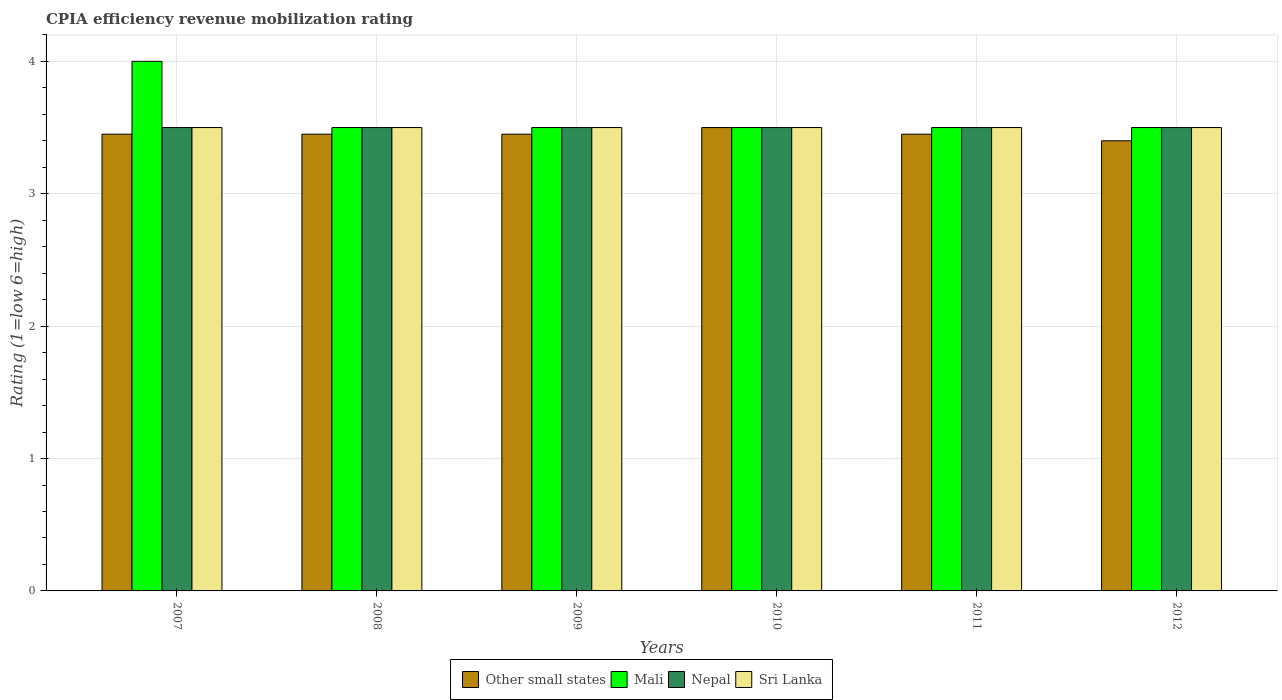How many different coloured bars are there?
Offer a terse response. 4. How many groups of bars are there?
Ensure brevity in your answer.  6. How many bars are there on the 6th tick from the right?
Your answer should be compact. 4. In how many cases, is the number of bars for a given year not equal to the number of legend labels?
Your response must be concise. 0. In which year was the CPIA rating in Nepal maximum?
Offer a very short reply. 2007. In which year was the CPIA rating in Sri Lanka minimum?
Offer a very short reply. 2007. What is the total CPIA rating in Mali in the graph?
Offer a very short reply. 21.5. What is the difference between the CPIA rating in Mali in 2007 and the CPIA rating in Nepal in 2008?
Offer a very short reply. 0.5. What is the average CPIA rating in Other small states per year?
Your answer should be very brief. 3.45. What is the ratio of the CPIA rating in Other small states in 2008 to that in 2011?
Give a very brief answer. 1. In how many years, is the CPIA rating in Mali greater than the average CPIA rating in Mali taken over all years?
Your answer should be very brief. 1. Is the sum of the CPIA rating in Mali in 2008 and 2012 greater than the maximum CPIA rating in Nepal across all years?
Your answer should be compact. Yes. Is it the case that in every year, the sum of the CPIA rating in Other small states and CPIA rating in Mali is greater than the sum of CPIA rating in Nepal and CPIA rating in Sri Lanka?
Your response must be concise. No. What does the 3rd bar from the left in 2008 represents?
Your answer should be very brief. Nepal. What does the 4th bar from the right in 2011 represents?
Your response must be concise. Other small states. Are all the bars in the graph horizontal?
Your answer should be compact. No. Are the values on the major ticks of Y-axis written in scientific E-notation?
Provide a short and direct response. No. Does the graph contain any zero values?
Your answer should be compact. No. Where does the legend appear in the graph?
Give a very brief answer. Bottom center. How many legend labels are there?
Your answer should be compact. 4. How are the legend labels stacked?
Keep it short and to the point. Horizontal. What is the title of the graph?
Offer a very short reply. CPIA efficiency revenue mobilization rating. What is the label or title of the X-axis?
Offer a very short reply. Years. What is the Rating (1=low 6=high) of Other small states in 2007?
Offer a terse response. 3.45. What is the Rating (1=low 6=high) of Mali in 2007?
Provide a succinct answer. 4. What is the Rating (1=low 6=high) in Nepal in 2007?
Your response must be concise. 3.5. What is the Rating (1=low 6=high) in Other small states in 2008?
Offer a very short reply. 3.45. What is the Rating (1=low 6=high) in Mali in 2008?
Provide a short and direct response. 3.5. What is the Rating (1=low 6=high) in Other small states in 2009?
Your answer should be compact. 3.45. What is the Rating (1=low 6=high) in Mali in 2009?
Offer a very short reply. 3.5. What is the Rating (1=low 6=high) of Mali in 2010?
Provide a short and direct response. 3.5. What is the Rating (1=low 6=high) of Nepal in 2010?
Your answer should be very brief. 3.5. What is the Rating (1=low 6=high) of Other small states in 2011?
Give a very brief answer. 3.45. What is the Rating (1=low 6=high) in Other small states in 2012?
Your response must be concise. 3.4. What is the Rating (1=low 6=high) in Mali in 2012?
Give a very brief answer. 3.5. What is the Rating (1=low 6=high) of Nepal in 2012?
Your answer should be compact. 3.5. Across all years, what is the maximum Rating (1=low 6=high) in Mali?
Make the answer very short. 4. Across all years, what is the maximum Rating (1=low 6=high) in Nepal?
Your answer should be compact. 3.5. Across all years, what is the minimum Rating (1=low 6=high) of Other small states?
Offer a terse response. 3.4. Across all years, what is the minimum Rating (1=low 6=high) in Mali?
Make the answer very short. 3.5. Across all years, what is the minimum Rating (1=low 6=high) of Sri Lanka?
Keep it short and to the point. 3.5. What is the total Rating (1=low 6=high) of Other small states in the graph?
Provide a short and direct response. 20.7. What is the total Rating (1=low 6=high) in Mali in the graph?
Your answer should be compact. 21.5. What is the total Rating (1=low 6=high) of Sri Lanka in the graph?
Offer a very short reply. 21. What is the difference between the Rating (1=low 6=high) in Other small states in 2007 and that in 2008?
Your answer should be compact. 0. What is the difference between the Rating (1=low 6=high) of Sri Lanka in 2007 and that in 2008?
Offer a terse response. 0. What is the difference between the Rating (1=low 6=high) of Other small states in 2007 and that in 2009?
Give a very brief answer. 0. What is the difference between the Rating (1=low 6=high) in Nepal in 2007 and that in 2009?
Offer a terse response. 0. What is the difference between the Rating (1=low 6=high) in Sri Lanka in 2007 and that in 2009?
Make the answer very short. 0. What is the difference between the Rating (1=low 6=high) in Other small states in 2007 and that in 2010?
Your response must be concise. -0.05. What is the difference between the Rating (1=low 6=high) in Mali in 2007 and that in 2010?
Your response must be concise. 0.5. What is the difference between the Rating (1=low 6=high) in Mali in 2007 and that in 2011?
Give a very brief answer. 0.5. What is the difference between the Rating (1=low 6=high) in Nepal in 2007 and that in 2011?
Make the answer very short. 0. What is the difference between the Rating (1=low 6=high) of Other small states in 2007 and that in 2012?
Ensure brevity in your answer.  0.05. What is the difference between the Rating (1=low 6=high) in Mali in 2007 and that in 2012?
Provide a succinct answer. 0.5. What is the difference between the Rating (1=low 6=high) in Nepal in 2007 and that in 2012?
Keep it short and to the point. 0. What is the difference between the Rating (1=low 6=high) of Sri Lanka in 2007 and that in 2012?
Provide a short and direct response. 0. What is the difference between the Rating (1=low 6=high) of Mali in 2008 and that in 2009?
Ensure brevity in your answer.  0. What is the difference between the Rating (1=low 6=high) in Sri Lanka in 2008 and that in 2009?
Keep it short and to the point. 0. What is the difference between the Rating (1=low 6=high) of Other small states in 2008 and that in 2010?
Keep it short and to the point. -0.05. What is the difference between the Rating (1=low 6=high) of Mali in 2008 and that in 2010?
Ensure brevity in your answer.  0. What is the difference between the Rating (1=low 6=high) in Other small states in 2008 and that in 2011?
Your answer should be compact. 0. What is the difference between the Rating (1=low 6=high) in Nepal in 2008 and that in 2011?
Offer a very short reply. 0. What is the difference between the Rating (1=low 6=high) in Other small states in 2008 and that in 2012?
Ensure brevity in your answer.  0.05. What is the difference between the Rating (1=low 6=high) of Mali in 2008 and that in 2012?
Provide a short and direct response. 0. What is the difference between the Rating (1=low 6=high) of Nepal in 2008 and that in 2012?
Your answer should be very brief. 0. What is the difference between the Rating (1=low 6=high) of Other small states in 2009 and that in 2011?
Your answer should be compact. 0. What is the difference between the Rating (1=low 6=high) of Nepal in 2009 and that in 2011?
Your answer should be compact. 0. What is the difference between the Rating (1=low 6=high) of Other small states in 2009 and that in 2012?
Provide a succinct answer. 0.05. What is the difference between the Rating (1=low 6=high) in Mali in 2009 and that in 2012?
Make the answer very short. 0. What is the difference between the Rating (1=low 6=high) in Nepal in 2009 and that in 2012?
Keep it short and to the point. 0. What is the difference between the Rating (1=low 6=high) in Sri Lanka in 2009 and that in 2012?
Your answer should be compact. 0. What is the difference between the Rating (1=low 6=high) in Nepal in 2010 and that in 2012?
Provide a short and direct response. 0. What is the difference between the Rating (1=low 6=high) of Other small states in 2011 and that in 2012?
Your answer should be compact. 0.05. What is the difference between the Rating (1=low 6=high) of Mali in 2011 and that in 2012?
Ensure brevity in your answer.  0. What is the difference between the Rating (1=low 6=high) in Other small states in 2007 and the Rating (1=low 6=high) in Mali in 2008?
Your response must be concise. -0.05. What is the difference between the Rating (1=low 6=high) in Other small states in 2007 and the Rating (1=low 6=high) in Sri Lanka in 2008?
Provide a short and direct response. -0.05. What is the difference between the Rating (1=low 6=high) in Other small states in 2007 and the Rating (1=low 6=high) in Mali in 2009?
Provide a short and direct response. -0.05. What is the difference between the Rating (1=low 6=high) in Other small states in 2007 and the Rating (1=low 6=high) in Sri Lanka in 2009?
Provide a succinct answer. -0.05. What is the difference between the Rating (1=low 6=high) of Mali in 2007 and the Rating (1=low 6=high) of Nepal in 2009?
Offer a terse response. 0.5. What is the difference between the Rating (1=low 6=high) of Mali in 2007 and the Rating (1=low 6=high) of Sri Lanka in 2009?
Provide a short and direct response. 0.5. What is the difference between the Rating (1=low 6=high) in Nepal in 2007 and the Rating (1=low 6=high) in Sri Lanka in 2009?
Ensure brevity in your answer.  0. What is the difference between the Rating (1=low 6=high) in Other small states in 2007 and the Rating (1=low 6=high) in Nepal in 2010?
Keep it short and to the point. -0.05. What is the difference between the Rating (1=low 6=high) of Other small states in 2007 and the Rating (1=low 6=high) of Sri Lanka in 2010?
Ensure brevity in your answer.  -0.05. What is the difference between the Rating (1=low 6=high) in Mali in 2007 and the Rating (1=low 6=high) in Nepal in 2011?
Provide a succinct answer. 0.5. What is the difference between the Rating (1=low 6=high) in Mali in 2007 and the Rating (1=low 6=high) in Sri Lanka in 2011?
Ensure brevity in your answer.  0.5. What is the difference between the Rating (1=low 6=high) in Other small states in 2007 and the Rating (1=low 6=high) in Nepal in 2012?
Your answer should be compact. -0.05. What is the difference between the Rating (1=low 6=high) of Other small states in 2007 and the Rating (1=low 6=high) of Sri Lanka in 2012?
Your answer should be very brief. -0.05. What is the difference between the Rating (1=low 6=high) of Mali in 2007 and the Rating (1=low 6=high) of Nepal in 2012?
Ensure brevity in your answer.  0.5. What is the difference between the Rating (1=low 6=high) of Other small states in 2008 and the Rating (1=low 6=high) of Mali in 2009?
Ensure brevity in your answer.  -0.05. What is the difference between the Rating (1=low 6=high) of Mali in 2008 and the Rating (1=low 6=high) of Nepal in 2009?
Keep it short and to the point. 0. What is the difference between the Rating (1=low 6=high) of Mali in 2008 and the Rating (1=low 6=high) of Sri Lanka in 2009?
Keep it short and to the point. 0. What is the difference between the Rating (1=low 6=high) of Nepal in 2008 and the Rating (1=low 6=high) of Sri Lanka in 2009?
Offer a very short reply. 0. What is the difference between the Rating (1=low 6=high) of Other small states in 2008 and the Rating (1=low 6=high) of Mali in 2010?
Offer a very short reply. -0.05. What is the difference between the Rating (1=low 6=high) of Mali in 2008 and the Rating (1=low 6=high) of Nepal in 2010?
Your response must be concise. 0. What is the difference between the Rating (1=low 6=high) in Mali in 2008 and the Rating (1=low 6=high) in Sri Lanka in 2010?
Provide a succinct answer. 0. What is the difference between the Rating (1=low 6=high) of Nepal in 2008 and the Rating (1=low 6=high) of Sri Lanka in 2010?
Offer a very short reply. 0. What is the difference between the Rating (1=low 6=high) in Other small states in 2008 and the Rating (1=low 6=high) in Mali in 2011?
Give a very brief answer. -0.05. What is the difference between the Rating (1=low 6=high) in Other small states in 2008 and the Rating (1=low 6=high) in Nepal in 2011?
Your answer should be compact. -0.05. What is the difference between the Rating (1=low 6=high) in Other small states in 2008 and the Rating (1=low 6=high) in Mali in 2012?
Offer a very short reply. -0.05. What is the difference between the Rating (1=low 6=high) in Other small states in 2008 and the Rating (1=low 6=high) in Sri Lanka in 2012?
Give a very brief answer. -0.05. What is the difference between the Rating (1=low 6=high) in Mali in 2008 and the Rating (1=low 6=high) in Sri Lanka in 2012?
Offer a terse response. 0. What is the difference between the Rating (1=low 6=high) in Other small states in 2009 and the Rating (1=low 6=high) in Nepal in 2010?
Your answer should be very brief. -0.05. What is the difference between the Rating (1=low 6=high) in Other small states in 2009 and the Rating (1=low 6=high) in Sri Lanka in 2010?
Provide a succinct answer. -0.05. What is the difference between the Rating (1=low 6=high) in Mali in 2009 and the Rating (1=low 6=high) in Nepal in 2010?
Your answer should be compact. 0. What is the difference between the Rating (1=low 6=high) in Other small states in 2009 and the Rating (1=low 6=high) in Mali in 2011?
Offer a very short reply. -0.05. What is the difference between the Rating (1=low 6=high) of Other small states in 2009 and the Rating (1=low 6=high) of Nepal in 2011?
Keep it short and to the point. -0.05. What is the difference between the Rating (1=low 6=high) in Other small states in 2009 and the Rating (1=low 6=high) in Sri Lanka in 2011?
Offer a very short reply. -0.05. What is the difference between the Rating (1=low 6=high) in Mali in 2009 and the Rating (1=low 6=high) in Nepal in 2011?
Offer a terse response. 0. What is the difference between the Rating (1=low 6=high) in Mali in 2009 and the Rating (1=low 6=high) in Sri Lanka in 2011?
Offer a terse response. 0. What is the difference between the Rating (1=low 6=high) of Other small states in 2009 and the Rating (1=low 6=high) of Mali in 2012?
Give a very brief answer. -0.05. What is the difference between the Rating (1=low 6=high) of Mali in 2009 and the Rating (1=low 6=high) of Sri Lanka in 2012?
Give a very brief answer. 0. What is the difference between the Rating (1=low 6=high) of Nepal in 2009 and the Rating (1=low 6=high) of Sri Lanka in 2012?
Offer a terse response. 0. What is the difference between the Rating (1=low 6=high) of Mali in 2010 and the Rating (1=low 6=high) of Nepal in 2011?
Ensure brevity in your answer.  0. What is the difference between the Rating (1=low 6=high) of Other small states in 2010 and the Rating (1=low 6=high) of Mali in 2012?
Your answer should be compact. 0. What is the difference between the Rating (1=low 6=high) of Other small states in 2010 and the Rating (1=low 6=high) of Nepal in 2012?
Make the answer very short. 0. What is the difference between the Rating (1=low 6=high) of Mali in 2010 and the Rating (1=low 6=high) of Nepal in 2012?
Make the answer very short. 0. What is the difference between the Rating (1=low 6=high) in Mali in 2010 and the Rating (1=low 6=high) in Sri Lanka in 2012?
Offer a terse response. 0. What is the difference between the Rating (1=low 6=high) of Nepal in 2010 and the Rating (1=low 6=high) of Sri Lanka in 2012?
Your answer should be compact. 0. What is the difference between the Rating (1=low 6=high) in Other small states in 2011 and the Rating (1=low 6=high) in Mali in 2012?
Provide a short and direct response. -0.05. What is the difference between the Rating (1=low 6=high) of Other small states in 2011 and the Rating (1=low 6=high) of Sri Lanka in 2012?
Offer a terse response. -0.05. What is the difference between the Rating (1=low 6=high) of Mali in 2011 and the Rating (1=low 6=high) of Sri Lanka in 2012?
Ensure brevity in your answer.  0. What is the average Rating (1=low 6=high) of Other small states per year?
Your response must be concise. 3.45. What is the average Rating (1=low 6=high) in Mali per year?
Offer a terse response. 3.58. What is the average Rating (1=low 6=high) of Nepal per year?
Your answer should be compact. 3.5. In the year 2007, what is the difference between the Rating (1=low 6=high) of Other small states and Rating (1=low 6=high) of Mali?
Offer a terse response. -0.55. In the year 2007, what is the difference between the Rating (1=low 6=high) of Other small states and Rating (1=low 6=high) of Nepal?
Provide a short and direct response. -0.05. In the year 2007, what is the difference between the Rating (1=low 6=high) in Other small states and Rating (1=low 6=high) in Sri Lanka?
Make the answer very short. -0.05. In the year 2007, what is the difference between the Rating (1=low 6=high) of Mali and Rating (1=low 6=high) of Sri Lanka?
Your response must be concise. 0.5. In the year 2008, what is the difference between the Rating (1=low 6=high) in Other small states and Rating (1=low 6=high) in Nepal?
Make the answer very short. -0.05. In the year 2009, what is the difference between the Rating (1=low 6=high) of Other small states and Rating (1=low 6=high) of Mali?
Offer a terse response. -0.05. In the year 2009, what is the difference between the Rating (1=low 6=high) of Other small states and Rating (1=low 6=high) of Nepal?
Provide a succinct answer. -0.05. In the year 2009, what is the difference between the Rating (1=low 6=high) in Mali and Rating (1=low 6=high) in Nepal?
Your response must be concise. 0. In the year 2009, what is the difference between the Rating (1=low 6=high) in Mali and Rating (1=low 6=high) in Sri Lanka?
Ensure brevity in your answer.  0. In the year 2009, what is the difference between the Rating (1=low 6=high) in Nepal and Rating (1=low 6=high) in Sri Lanka?
Provide a succinct answer. 0. In the year 2010, what is the difference between the Rating (1=low 6=high) of Mali and Rating (1=low 6=high) of Nepal?
Your answer should be very brief. 0. In the year 2010, what is the difference between the Rating (1=low 6=high) of Mali and Rating (1=low 6=high) of Sri Lanka?
Give a very brief answer. 0. In the year 2011, what is the difference between the Rating (1=low 6=high) in Other small states and Rating (1=low 6=high) in Mali?
Offer a terse response. -0.05. In the year 2011, what is the difference between the Rating (1=low 6=high) in Other small states and Rating (1=low 6=high) in Nepal?
Keep it short and to the point. -0.05. In the year 2011, what is the difference between the Rating (1=low 6=high) of Nepal and Rating (1=low 6=high) of Sri Lanka?
Offer a terse response. 0. In the year 2012, what is the difference between the Rating (1=low 6=high) of Mali and Rating (1=low 6=high) of Sri Lanka?
Your response must be concise. 0. What is the ratio of the Rating (1=low 6=high) in Other small states in 2007 to that in 2008?
Your response must be concise. 1. What is the ratio of the Rating (1=low 6=high) of Nepal in 2007 to that in 2008?
Your answer should be compact. 1. What is the ratio of the Rating (1=low 6=high) in Other small states in 2007 to that in 2009?
Provide a short and direct response. 1. What is the ratio of the Rating (1=low 6=high) of Other small states in 2007 to that in 2010?
Offer a very short reply. 0.99. What is the ratio of the Rating (1=low 6=high) of Other small states in 2007 to that in 2011?
Provide a succinct answer. 1. What is the ratio of the Rating (1=low 6=high) of Nepal in 2007 to that in 2011?
Your answer should be very brief. 1. What is the ratio of the Rating (1=low 6=high) of Other small states in 2007 to that in 2012?
Your answer should be compact. 1.01. What is the ratio of the Rating (1=low 6=high) of Mali in 2007 to that in 2012?
Provide a succinct answer. 1.14. What is the ratio of the Rating (1=low 6=high) of Nepal in 2007 to that in 2012?
Provide a short and direct response. 1. What is the ratio of the Rating (1=low 6=high) of Other small states in 2008 to that in 2009?
Your answer should be compact. 1. What is the ratio of the Rating (1=low 6=high) of Mali in 2008 to that in 2009?
Make the answer very short. 1. What is the ratio of the Rating (1=low 6=high) in Nepal in 2008 to that in 2009?
Your answer should be very brief. 1. What is the ratio of the Rating (1=low 6=high) of Sri Lanka in 2008 to that in 2009?
Your answer should be very brief. 1. What is the ratio of the Rating (1=low 6=high) in Other small states in 2008 to that in 2010?
Give a very brief answer. 0.99. What is the ratio of the Rating (1=low 6=high) in Sri Lanka in 2008 to that in 2010?
Provide a succinct answer. 1. What is the ratio of the Rating (1=low 6=high) in Other small states in 2008 to that in 2011?
Ensure brevity in your answer.  1. What is the ratio of the Rating (1=low 6=high) of Mali in 2008 to that in 2011?
Provide a succinct answer. 1. What is the ratio of the Rating (1=low 6=high) of Nepal in 2008 to that in 2011?
Ensure brevity in your answer.  1. What is the ratio of the Rating (1=low 6=high) of Other small states in 2008 to that in 2012?
Ensure brevity in your answer.  1.01. What is the ratio of the Rating (1=low 6=high) in Mali in 2008 to that in 2012?
Provide a succinct answer. 1. What is the ratio of the Rating (1=low 6=high) of Nepal in 2008 to that in 2012?
Provide a short and direct response. 1. What is the ratio of the Rating (1=low 6=high) in Other small states in 2009 to that in 2010?
Your answer should be compact. 0.99. What is the ratio of the Rating (1=low 6=high) in Mali in 2009 to that in 2011?
Provide a succinct answer. 1. What is the ratio of the Rating (1=low 6=high) of Nepal in 2009 to that in 2011?
Offer a terse response. 1. What is the ratio of the Rating (1=low 6=high) of Sri Lanka in 2009 to that in 2011?
Offer a very short reply. 1. What is the ratio of the Rating (1=low 6=high) of Other small states in 2009 to that in 2012?
Keep it short and to the point. 1.01. What is the ratio of the Rating (1=low 6=high) of Mali in 2009 to that in 2012?
Give a very brief answer. 1. What is the ratio of the Rating (1=low 6=high) of Nepal in 2009 to that in 2012?
Ensure brevity in your answer.  1. What is the ratio of the Rating (1=low 6=high) of Other small states in 2010 to that in 2011?
Ensure brevity in your answer.  1.01. What is the ratio of the Rating (1=low 6=high) in Sri Lanka in 2010 to that in 2011?
Your answer should be compact. 1. What is the ratio of the Rating (1=low 6=high) in Other small states in 2010 to that in 2012?
Your answer should be compact. 1.03. What is the ratio of the Rating (1=low 6=high) in Nepal in 2010 to that in 2012?
Your response must be concise. 1. What is the ratio of the Rating (1=low 6=high) of Sri Lanka in 2010 to that in 2012?
Your answer should be compact. 1. What is the ratio of the Rating (1=low 6=high) in Other small states in 2011 to that in 2012?
Ensure brevity in your answer.  1.01. What is the ratio of the Rating (1=low 6=high) of Nepal in 2011 to that in 2012?
Your answer should be compact. 1. What is the ratio of the Rating (1=low 6=high) in Sri Lanka in 2011 to that in 2012?
Offer a very short reply. 1. What is the difference between the highest and the second highest Rating (1=low 6=high) in Nepal?
Keep it short and to the point. 0. What is the difference between the highest and the lowest Rating (1=low 6=high) of Mali?
Offer a very short reply. 0.5. What is the difference between the highest and the lowest Rating (1=low 6=high) in Nepal?
Ensure brevity in your answer.  0. What is the difference between the highest and the lowest Rating (1=low 6=high) in Sri Lanka?
Your answer should be very brief. 0. 